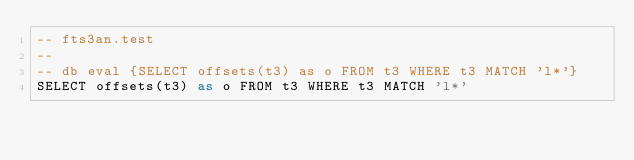<code> <loc_0><loc_0><loc_500><loc_500><_SQL_>-- fts3an.test
-- 
-- db eval {SELECT offsets(t3) as o FROM t3 WHERE t3 MATCH 'l*'}
SELECT offsets(t3) as o FROM t3 WHERE t3 MATCH 'l*'</code> 